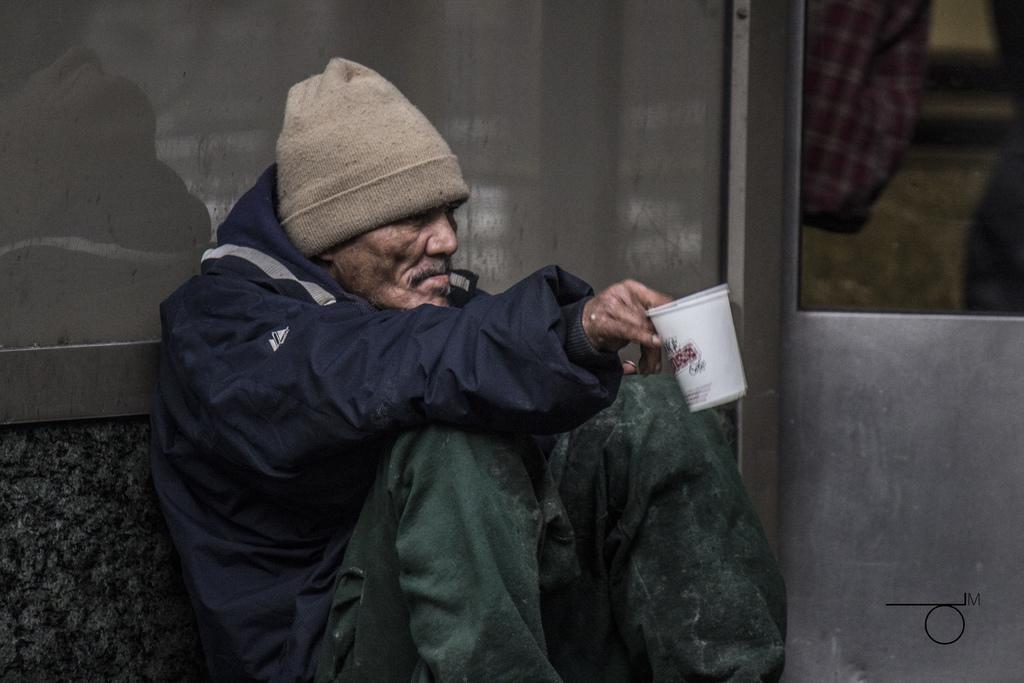In one or two sentences, can you explain what this image depicts? In this image, we can see a person in front of the wall holding a cup with his hand. This person is wearing clothes and cap. 